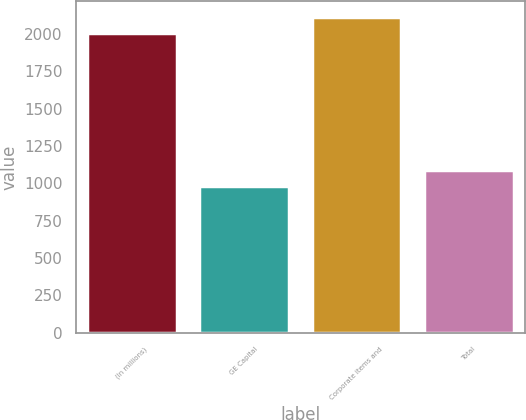Convert chart. <chart><loc_0><loc_0><loc_500><loc_500><bar_chart><fcel>(In millions)<fcel>GE Capital<fcel>Corporate items and<fcel>Total<nl><fcel>2010<fcel>985<fcel>2113.9<fcel>1088.9<nl></chart> 